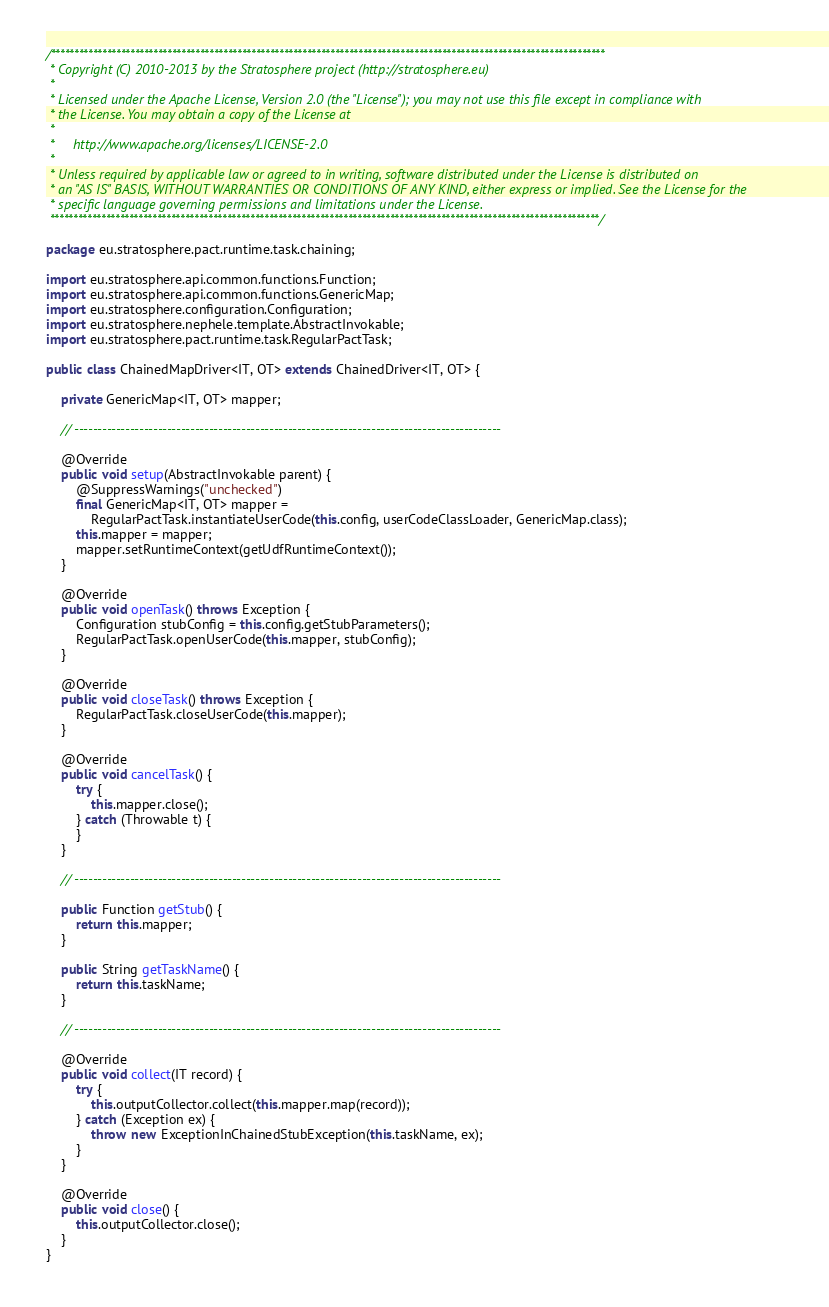Convert code to text. <code><loc_0><loc_0><loc_500><loc_500><_Java_>/***********************************************************************************************************************
 * Copyright (C) 2010-2013 by the Stratosphere project (http://stratosphere.eu)
 *
 * Licensed under the Apache License, Version 2.0 (the "License"); you may not use this file except in compliance with
 * the License. You may obtain a copy of the License at
 *
 *     http://www.apache.org/licenses/LICENSE-2.0
 *
 * Unless required by applicable law or agreed to in writing, software distributed under the License is distributed on
 * an "AS IS" BASIS, WITHOUT WARRANTIES OR CONDITIONS OF ANY KIND, either express or implied. See the License for the
 * specific language governing permissions and limitations under the License.
 **********************************************************************************************************************/

package eu.stratosphere.pact.runtime.task.chaining;

import eu.stratosphere.api.common.functions.Function;
import eu.stratosphere.api.common.functions.GenericMap;
import eu.stratosphere.configuration.Configuration;
import eu.stratosphere.nephele.template.AbstractInvokable;
import eu.stratosphere.pact.runtime.task.RegularPactTask;

public class ChainedMapDriver<IT, OT> extends ChainedDriver<IT, OT> {

	private GenericMap<IT, OT> mapper;

	// --------------------------------------------------------------------------------------------

	@Override
	public void setup(AbstractInvokable parent) {
		@SuppressWarnings("unchecked")
		final GenericMap<IT, OT> mapper =
			RegularPactTask.instantiateUserCode(this.config, userCodeClassLoader, GenericMap.class);
		this.mapper = mapper;
		mapper.setRuntimeContext(getUdfRuntimeContext());
	}

	@Override
	public void openTask() throws Exception {
		Configuration stubConfig = this.config.getStubParameters();
		RegularPactTask.openUserCode(this.mapper, stubConfig);
	}

	@Override
	public void closeTask() throws Exception {
		RegularPactTask.closeUserCode(this.mapper);
	}

	@Override
	public void cancelTask() {
		try {
			this.mapper.close();
		} catch (Throwable t) {
		}
	}

	// --------------------------------------------------------------------------------------------

	public Function getStub() {
		return this.mapper;
	}

	public String getTaskName() {
		return this.taskName;
	}

	// --------------------------------------------------------------------------------------------

	@Override
	public void collect(IT record) {
		try {
			this.outputCollector.collect(this.mapper.map(record));
		} catch (Exception ex) {
			throw new ExceptionInChainedStubException(this.taskName, ex);
		}
	}

	@Override
	public void close() {
		this.outputCollector.close();
	}
}
</code> 